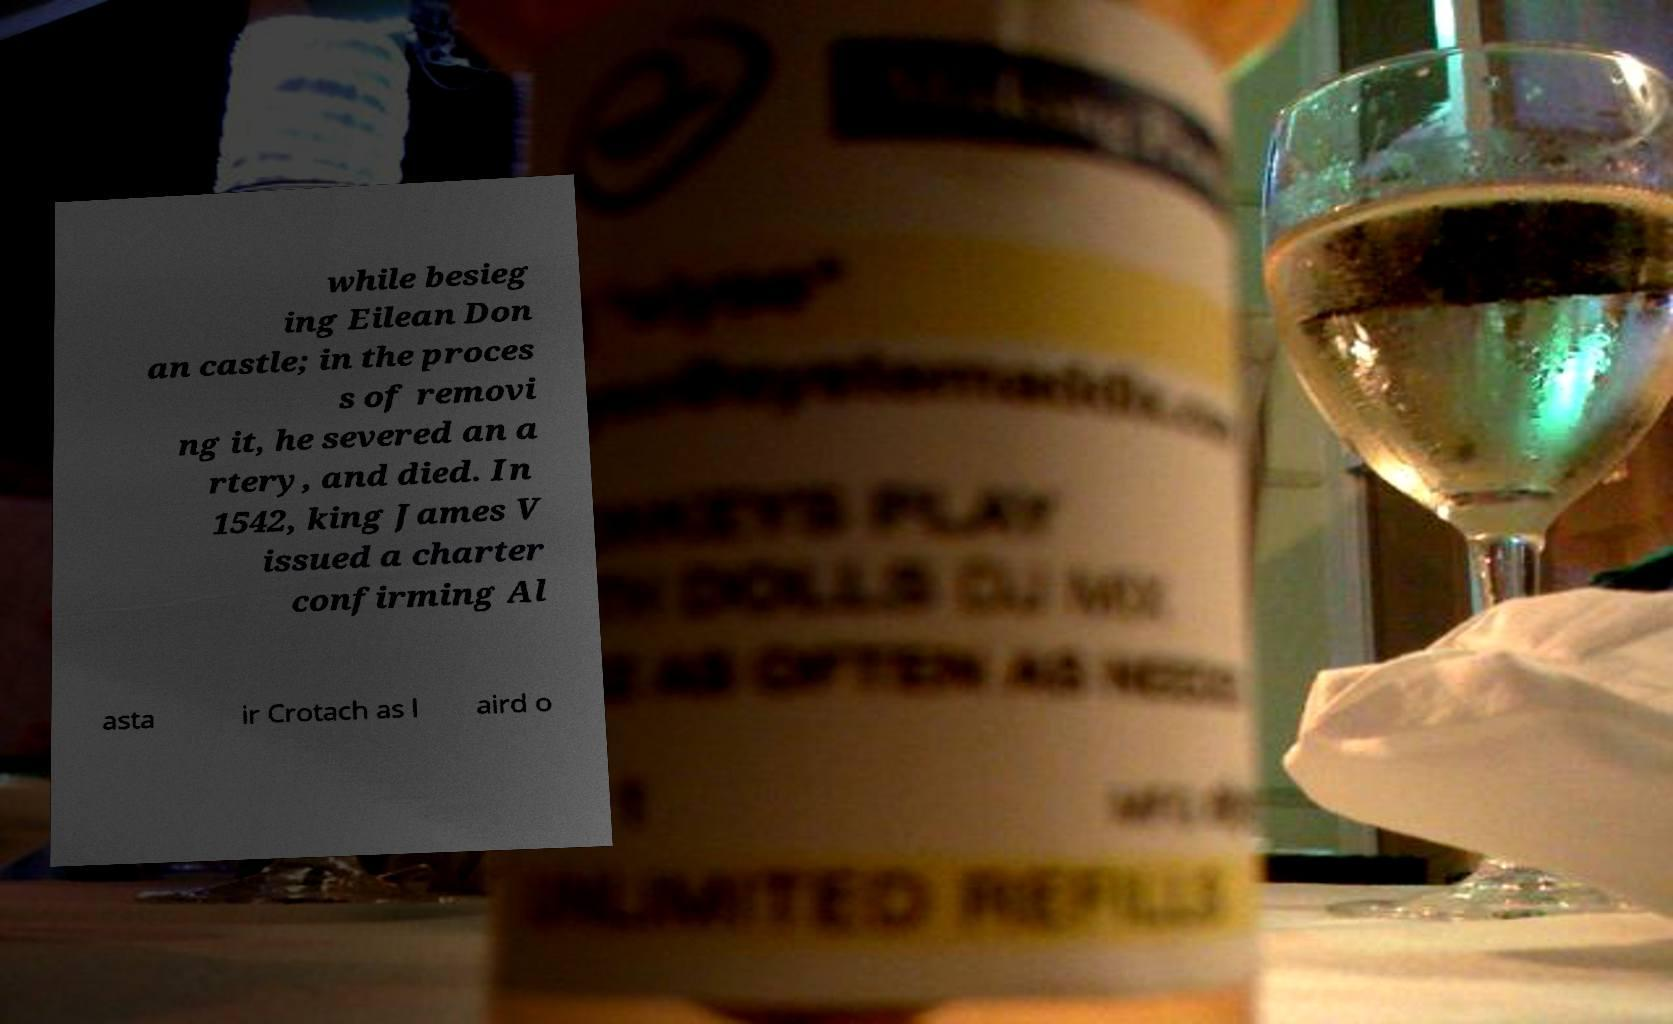Could you extract and type out the text from this image? while besieg ing Eilean Don an castle; in the proces s of removi ng it, he severed an a rtery, and died. In 1542, king James V issued a charter confirming Al asta ir Crotach as l aird o 